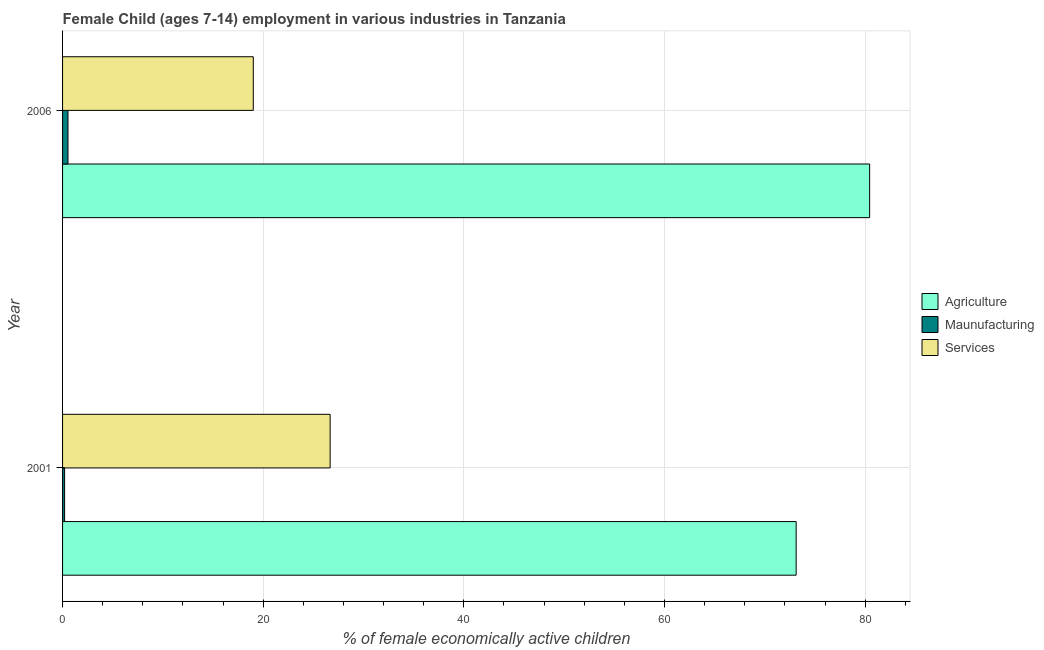How many different coloured bars are there?
Keep it short and to the point. 3. How many bars are there on the 1st tick from the top?
Your answer should be compact. 3. What is the label of the 1st group of bars from the top?
Offer a very short reply. 2006. What is the percentage of economically active children in agriculture in 2006?
Keep it short and to the point. 80.45. Across all years, what is the maximum percentage of economically active children in services?
Offer a very short reply. 26.67. Across all years, what is the minimum percentage of economically active children in agriculture?
Give a very brief answer. 73.12. What is the total percentage of economically active children in services in the graph?
Your answer should be compact. 45.68. What is the difference between the percentage of economically active children in agriculture in 2001 and that in 2006?
Make the answer very short. -7.33. What is the difference between the percentage of economically active children in services in 2006 and the percentage of economically active children in agriculture in 2001?
Offer a very short reply. -54.11. What is the average percentage of economically active children in manufacturing per year?
Offer a very short reply. 0.37. In the year 2006, what is the difference between the percentage of economically active children in agriculture and percentage of economically active children in services?
Your answer should be compact. 61.44. In how many years, is the percentage of economically active children in manufacturing greater than 40 %?
Your answer should be very brief. 0. What is the ratio of the percentage of economically active children in services in 2001 to that in 2006?
Offer a terse response. 1.4. What does the 2nd bar from the top in 2001 represents?
Keep it short and to the point. Maunufacturing. What does the 1st bar from the bottom in 2006 represents?
Offer a terse response. Agriculture. How many bars are there?
Provide a succinct answer. 6. Are all the bars in the graph horizontal?
Ensure brevity in your answer.  Yes. Does the graph contain any zero values?
Make the answer very short. No. Does the graph contain grids?
Ensure brevity in your answer.  Yes. How many legend labels are there?
Give a very brief answer. 3. How are the legend labels stacked?
Offer a terse response. Vertical. What is the title of the graph?
Keep it short and to the point. Female Child (ages 7-14) employment in various industries in Tanzania. Does "Domestic economy" appear as one of the legend labels in the graph?
Ensure brevity in your answer.  No. What is the label or title of the X-axis?
Make the answer very short. % of female economically active children. What is the label or title of the Y-axis?
Offer a terse response. Year. What is the % of female economically active children of Agriculture in 2001?
Provide a succinct answer. 73.12. What is the % of female economically active children in Maunufacturing in 2001?
Offer a very short reply. 0.2. What is the % of female economically active children of Services in 2001?
Ensure brevity in your answer.  26.67. What is the % of female economically active children in Agriculture in 2006?
Make the answer very short. 80.45. What is the % of female economically active children in Maunufacturing in 2006?
Your answer should be compact. 0.54. What is the % of female economically active children in Services in 2006?
Provide a short and direct response. 19.01. Across all years, what is the maximum % of female economically active children in Agriculture?
Provide a short and direct response. 80.45. Across all years, what is the maximum % of female economically active children in Maunufacturing?
Keep it short and to the point. 0.54. Across all years, what is the maximum % of female economically active children in Services?
Offer a very short reply. 26.67. Across all years, what is the minimum % of female economically active children in Agriculture?
Offer a very short reply. 73.12. Across all years, what is the minimum % of female economically active children in Maunufacturing?
Provide a succinct answer. 0.2. Across all years, what is the minimum % of female economically active children in Services?
Ensure brevity in your answer.  19.01. What is the total % of female economically active children of Agriculture in the graph?
Keep it short and to the point. 153.57. What is the total % of female economically active children in Maunufacturing in the graph?
Your answer should be very brief. 0.74. What is the total % of female economically active children of Services in the graph?
Make the answer very short. 45.68. What is the difference between the % of female economically active children of Agriculture in 2001 and that in 2006?
Your response must be concise. -7.33. What is the difference between the % of female economically active children of Maunufacturing in 2001 and that in 2006?
Your response must be concise. -0.34. What is the difference between the % of female economically active children of Services in 2001 and that in 2006?
Your answer should be compact. 7.66. What is the difference between the % of female economically active children in Agriculture in 2001 and the % of female economically active children in Maunufacturing in 2006?
Your answer should be compact. 72.58. What is the difference between the % of female economically active children in Agriculture in 2001 and the % of female economically active children in Services in 2006?
Provide a succinct answer. 54.11. What is the difference between the % of female economically active children of Maunufacturing in 2001 and the % of female economically active children of Services in 2006?
Provide a succinct answer. -18.81. What is the average % of female economically active children in Agriculture per year?
Keep it short and to the point. 76.79. What is the average % of female economically active children of Maunufacturing per year?
Keep it short and to the point. 0.37. What is the average % of female economically active children in Services per year?
Offer a terse response. 22.84. In the year 2001, what is the difference between the % of female economically active children of Agriculture and % of female economically active children of Maunufacturing?
Offer a terse response. 72.92. In the year 2001, what is the difference between the % of female economically active children of Agriculture and % of female economically active children of Services?
Your answer should be very brief. 46.45. In the year 2001, what is the difference between the % of female economically active children in Maunufacturing and % of female economically active children in Services?
Offer a very short reply. -26.47. In the year 2006, what is the difference between the % of female economically active children in Agriculture and % of female economically active children in Maunufacturing?
Provide a succinct answer. 79.91. In the year 2006, what is the difference between the % of female economically active children in Agriculture and % of female economically active children in Services?
Make the answer very short. 61.44. In the year 2006, what is the difference between the % of female economically active children in Maunufacturing and % of female economically active children in Services?
Your response must be concise. -18.47. What is the ratio of the % of female economically active children in Agriculture in 2001 to that in 2006?
Ensure brevity in your answer.  0.91. What is the ratio of the % of female economically active children in Maunufacturing in 2001 to that in 2006?
Provide a short and direct response. 0.38. What is the ratio of the % of female economically active children in Services in 2001 to that in 2006?
Your answer should be compact. 1.4. What is the difference between the highest and the second highest % of female economically active children in Agriculture?
Your answer should be very brief. 7.33. What is the difference between the highest and the second highest % of female economically active children in Maunufacturing?
Provide a short and direct response. 0.34. What is the difference between the highest and the second highest % of female economically active children of Services?
Give a very brief answer. 7.66. What is the difference between the highest and the lowest % of female economically active children of Agriculture?
Your response must be concise. 7.33. What is the difference between the highest and the lowest % of female economically active children of Maunufacturing?
Give a very brief answer. 0.34. What is the difference between the highest and the lowest % of female economically active children of Services?
Ensure brevity in your answer.  7.66. 